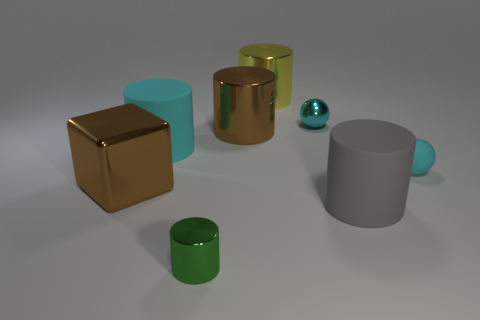The small metal object that is behind the block has what shape?
Provide a succinct answer. Sphere. There is a green metal object; is its shape the same as the large object that is right of the large yellow thing?
Provide a short and direct response. Yes. There is a shiny object that is behind the big gray matte cylinder and in front of the brown metallic cylinder; what size is it?
Offer a terse response. Large. What is the color of the tiny thing that is in front of the shiny ball and right of the small metal cylinder?
Your answer should be very brief. Cyan. Are there fewer gray objects that are right of the big gray object than large cyan cylinders that are behind the cyan shiny ball?
Your answer should be compact. No. Is there anything else of the same color as the metallic cube?
Ensure brevity in your answer.  Yes. There is a gray thing; what shape is it?
Provide a short and direct response. Cylinder. What is the color of the small sphere that is the same material as the cyan cylinder?
Make the answer very short. Cyan. Is the number of spheres greater than the number of big cyan objects?
Offer a very short reply. Yes. Are there any big brown shiny objects?
Your answer should be very brief. Yes. 